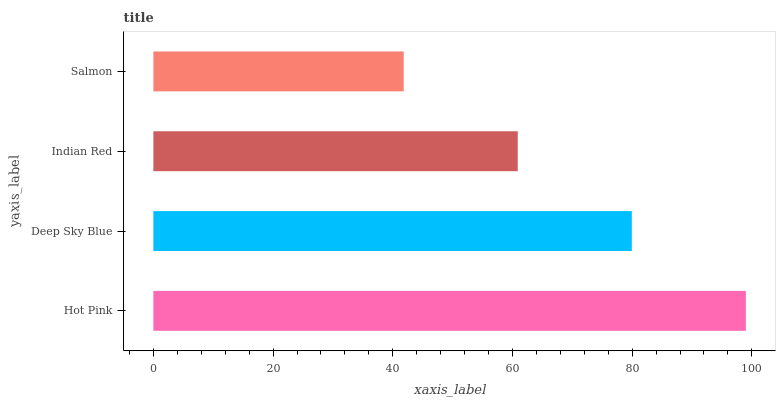Is Salmon the minimum?
Answer yes or no. Yes. Is Hot Pink the maximum?
Answer yes or no. Yes. Is Deep Sky Blue the minimum?
Answer yes or no. No. Is Deep Sky Blue the maximum?
Answer yes or no. No. Is Hot Pink greater than Deep Sky Blue?
Answer yes or no. Yes. Is Deep Sky Blue less than Hot Pink?
Answer yes or no. Yes. Is Deep Sky Blue greater than Hot Pink?
Answer yes or no. No. Is Hot Pink less than Deep Sky Blue?
Answer yes or no. No. Is Deep Sky Blue the high median?
Answer yes or no. Yes. Is Indian Red the low median?
Answer yes or no. Yes. Is Salmon the high median?
Answer yes or no. No. Is Salmon the low median?
Answer yes or no. No. 